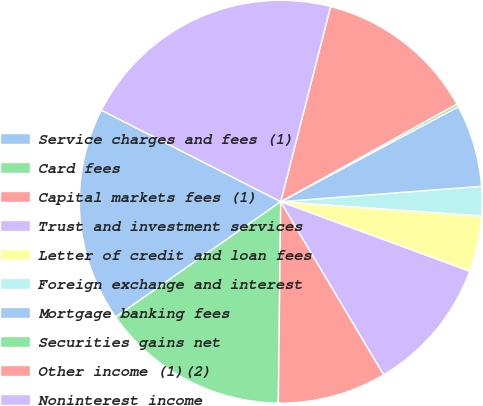Convert chart. <chart><loc_0><loc_0><loc_500><loc_500><pie_chart><fcel>Service charges and fees (1)<fcel>Card fees<fcel>Capital markets fees (1)<fcel>Trust and investment services<fcel>Letter of credit and loan fees<fcel>Foreign exchange and interest<fcel>Mortgage banking fees<fcel>Securities gains net<fcel>Other income (1)(2)<fcel>Noninterest income<nl><fcel>17.22%<fcel>15.1%<fcel>8.73%<fcel>10.85%<fcel>4.48%<fcel>2.35%<fcel>6.6%<fcel>0.23%<fcel>12.97%<fcel>21.47%<nl></chart> 